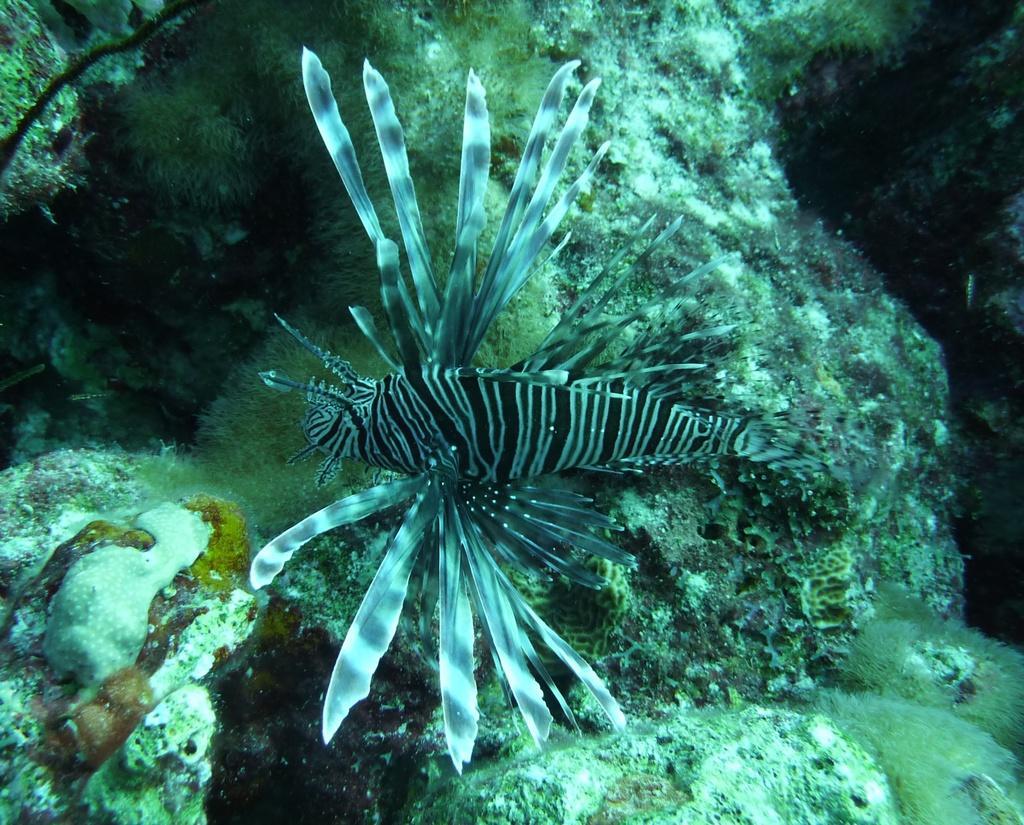In one or two sentences, can you explain what this image depicts? In this image I see an aquatic animal which is of white and black in color. 